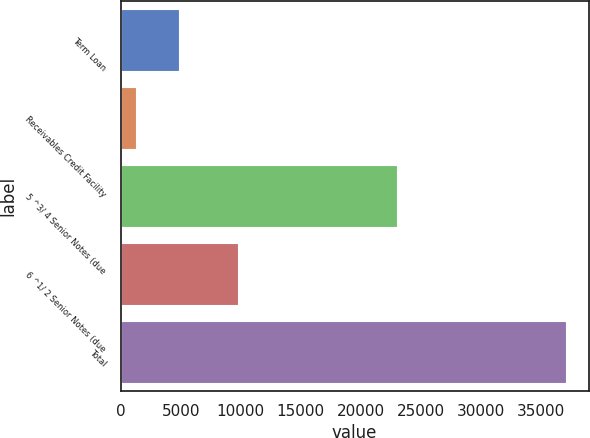<chart> <loc_0><loc_0><loc_500><loc_500><bar_chart><fcel>Term Loan<fcel>Receivables Credit Facility<fcel>5 ^3/ 4 Senior Notes (due<fcel>6 ^1/ 2 Senior Notes (due<fcel>Total<nl><fcel>4841<fcel>1254<fcel>23000<fcel>9750<fcel>37124<nl></chart> 